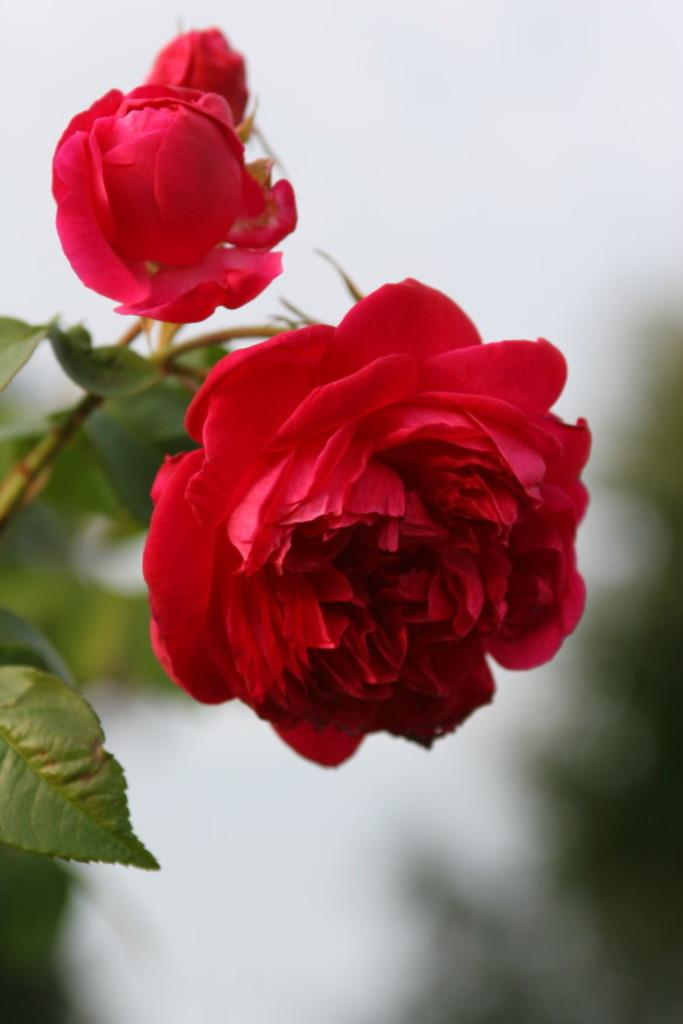What type of plant is visible in the image? There is a plant with flowers in the image. How would you describe the background of the image? The background of the image is blurred. What part of the natural environment can be seen in the image? The sky is visible in the background of the image. What type of suit is the plant wearing in the image? There is no suit present in the image, as the subject is a plant with flowers. What material is the brass used for in the image? There is no brass present in the image. 